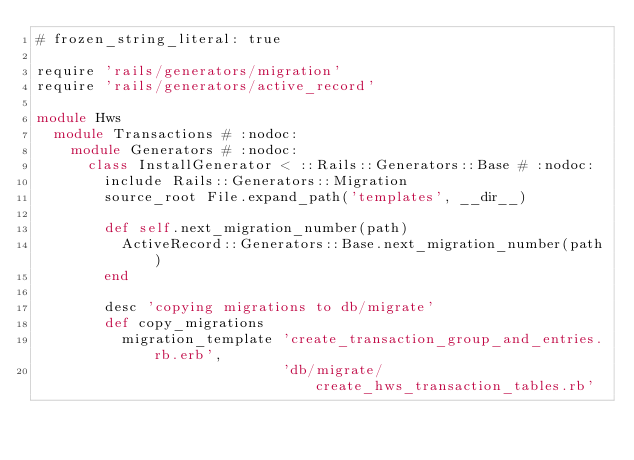<code> <loc_0><loc_0><loc_500><loc_500><_Ruby_># frozen_string_literal: true

require 'rails/generators/migration'
require 'rails/generators/active_record'

module Hws
  module Transactions # :nodoc:
    module Generators # :nodoc:
      class InstallGenerator < ::Rails::Generators::Base # :nodoc:
        include Rails::Generators::Migration
        source_root File.expand_path('templates', __dir__)

        def self.next_migration_number(path)
          ActiveRecord::Generators::Base.next_migration_number(path)
        end

        desc 'copying migrations to db/migrate'
        def copy_migrations
          migration_template 'create_transaction_group_and_entries.rb.erb',
                             'db/migrate/create_hws_transaction_tables.rb'</code> 